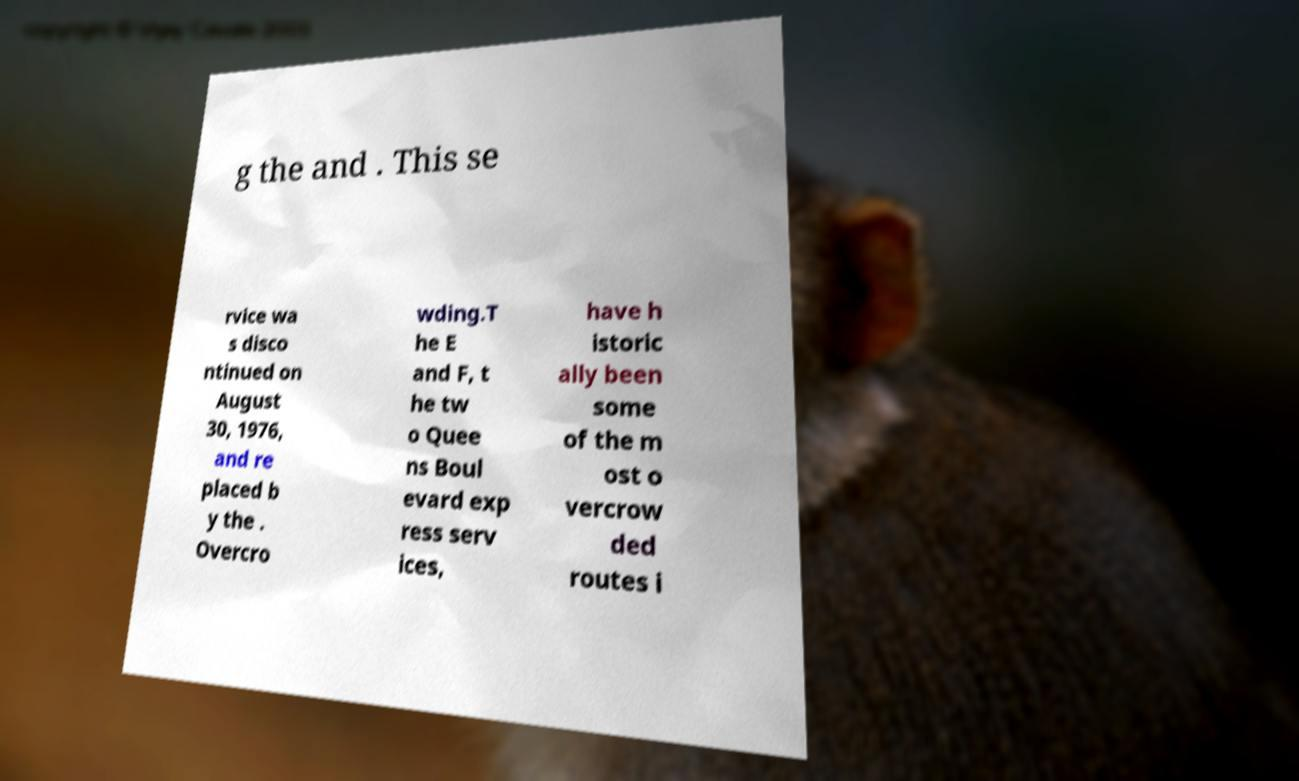For documentation purposes, I need the text within this image transcribed. Could you provide that? g the and . This se rvice wa s disco ntinued on August 30, 1976, and re placed b y the . Overcro wding.T he E and F, t he tw o Quee ns Boul evard exp ress serv ices, have h istoric ally been some of the m ost o vercrow ded routes i 